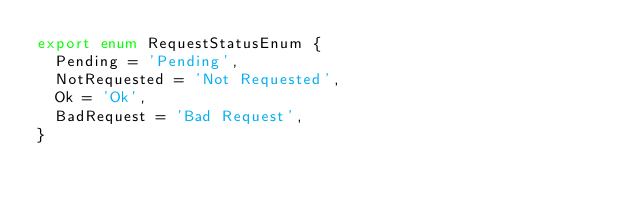<code> <loc_0><loc_0><loc_500><loc_500><_TypeScript_>export enum RequestStatusEnum {
  Pending = 'Pending',
  NotRequested = 'Not Requested',
  Ok = 'Ok',
  BadRequest = 'Bad Request',
}
</code> 